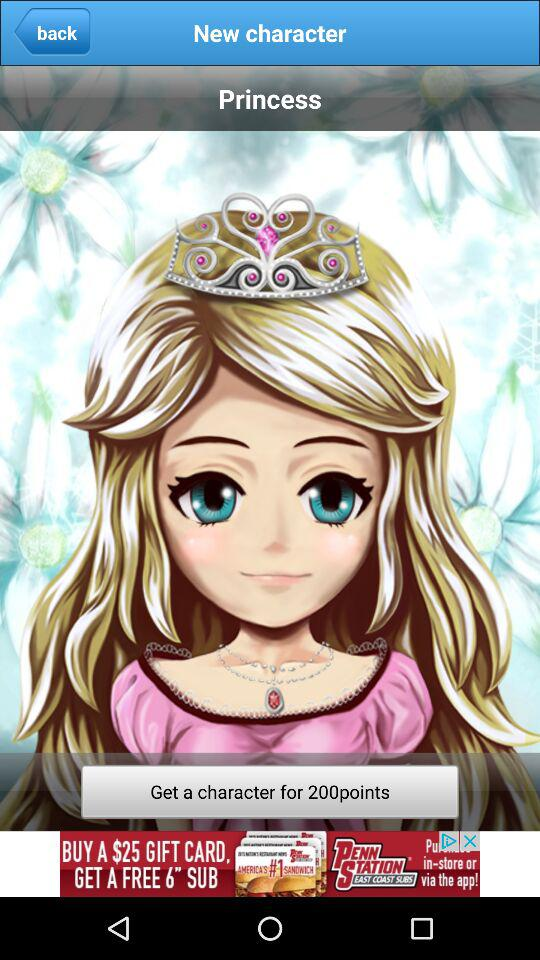What is a new character? The new character is "Princess". 